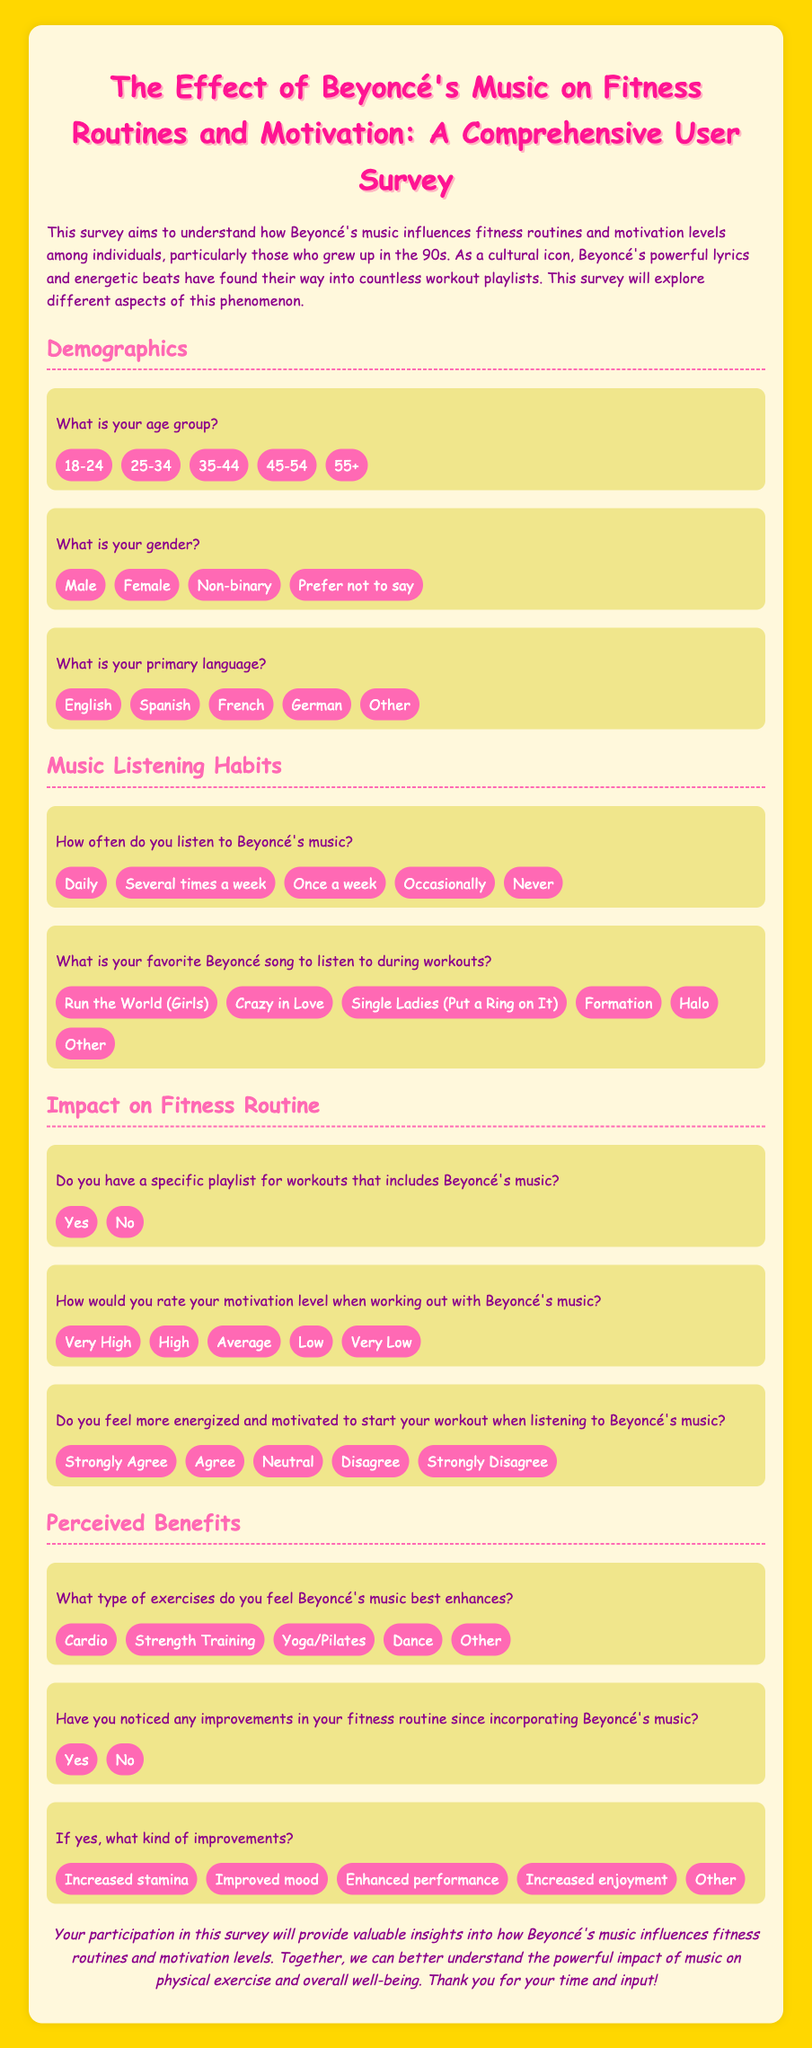What is the title of the survey? The title of the survey is stated prominently at the top of the document, indicating its focus on Beyoncé's music and fitness.
Answer: The Effect of Beyoncé's Music on Fitness Routines and Motivation: A Comprehensive User Survey What is the age group option that includes individuals aged 25-34? The document lists various age group options under the demographics section, and one of them corresponds to this age range.
Answer: 25-34 How often do respondents listen to Beyoncé's music according to the options provided? The survey includes a question about the frequency of listening to Beyoncé's music, which has multiple choice answers indicating different frequencies.
Answer: Daily What type of exercise is mentioned that Beyoncé's music enhances? The survey asks respondents which type of exercises Beyoncé's music best enhances, providing several options related to fitness routines.
Answer: Cardio What rating options are available for motivation levels when working out with Beyoncé's music? The motivation level question offers several ratings, each corresponding to different levels of motivation experienced by the respondents.
Answer: Very High, High, Average, Low, Very Low Do respondents have a specific playlist for workouts that includes Beyoncé's music? One of the survey questions directly asks if respondents include Beyoncé's music in a workout playlist, reflecting on their music habits while exercising.
Answer: Yes What is a perceived benefit of listening to Beyoncé's music during workouts? The survey includes a question regarding the types of benefits respondents have noticed since incorporating Beyoncé's music into their fitness routines.
Answer: Increased stamina What is the primary language option related to the survey? The survey asks participants for their primary language, providing a range of options reflecting linguistic diversity.
Answer: English Have respondents noted any improvements in their fitness routine since incorporating Beyoncé's music? The survey includes options for respondents to indicate whether they have experienced improvements in their fitness routines due to Beyoncé's music.
Answer: Yes 